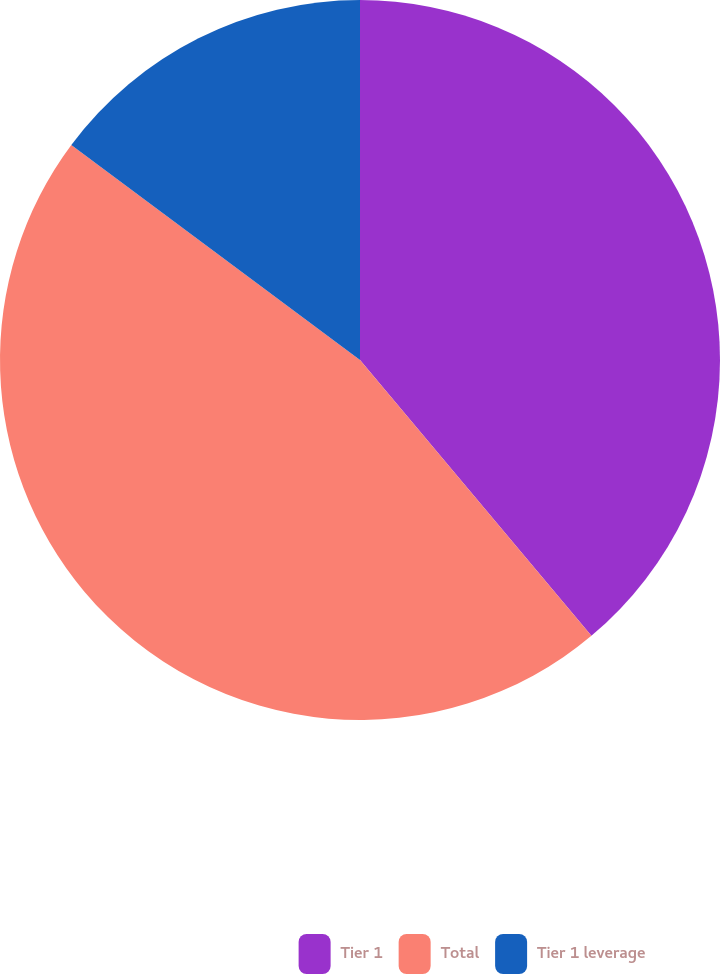Convert chart to OTSL. <chart><loc_0><loc_0><loc_500><loc_500><pie_chart><fcel>Tier 1<fcel>Total<fcel>Tier 1 leverage<nl><fcel>38.89%<fcel>46.3%<fcel>14.81%<nl></chart> 